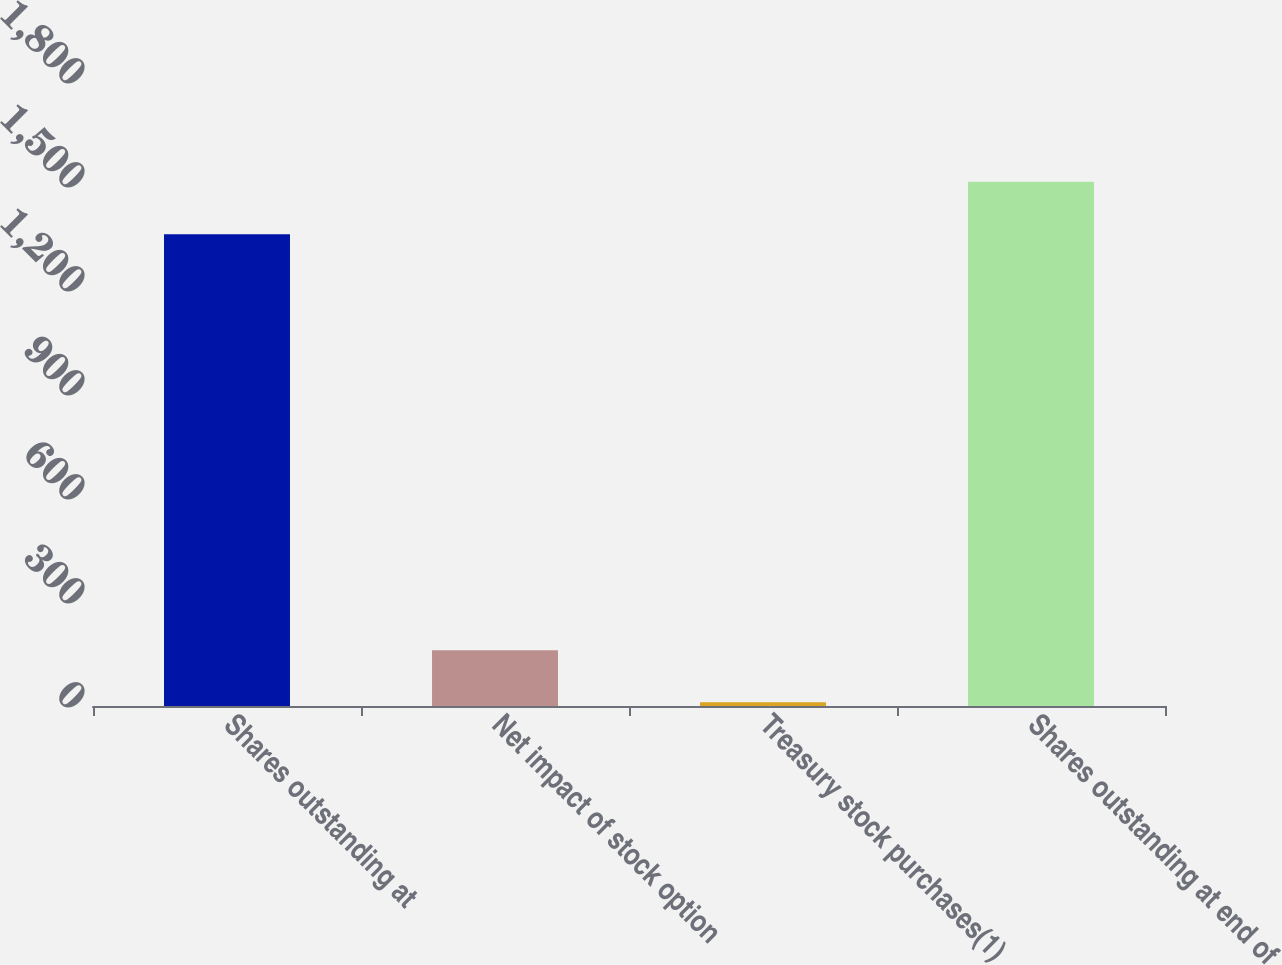Convert chart. <chart><loc_0><loc_0><loc_500><loc_500><bar_chart><fcel>Shares outstanding at<fcel>Net impact of stock option<fcel>Treasury stock purchases(1)<fcel>Shares outstanding at end of<nl><fcel>1361<fcel>161.1<fcel>11<fcel>1512<nl></chart> 